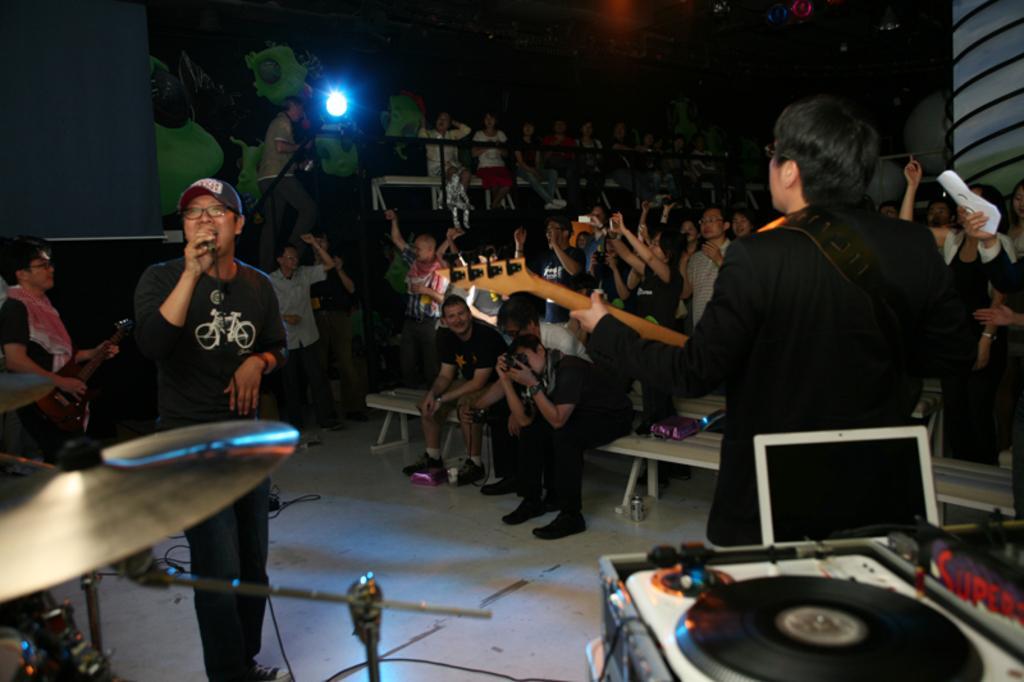How would you summarize this image in a sentence or two? Bottom left side of the image there is a drum. Behind the drum a person is standing and holding a microphone. Bottom right side of the image there is a musical devices. Behind them a man is standing and holding a guitar. Behind them few people are standing and sitting on benches. Top of the image there is wall and light. 